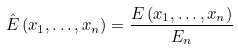<formula> <loc_0><loc_0><loc_500><loc_500>\hat { E } \left ( x _ { 1 } , \dots , x _ { n } \right ) = \frac { E \left ( x _ { 1 } , \dots , x _ { n } \right ) } { E _ { n } }</formula> 